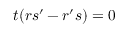<formula> <loc_0><loc_0><loc_500><loc_500>t ( r s ^ { \prime } - r ^ { \prime } s ) = 0</formula> 